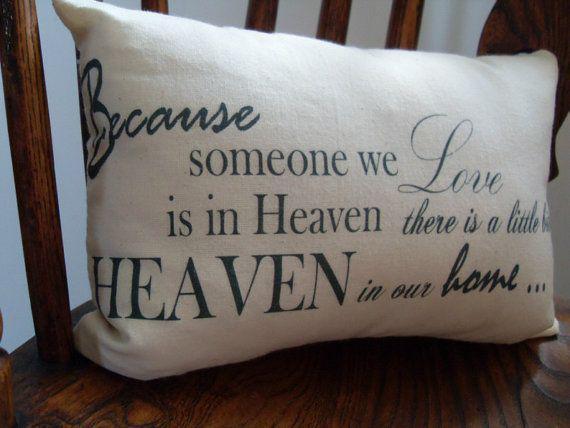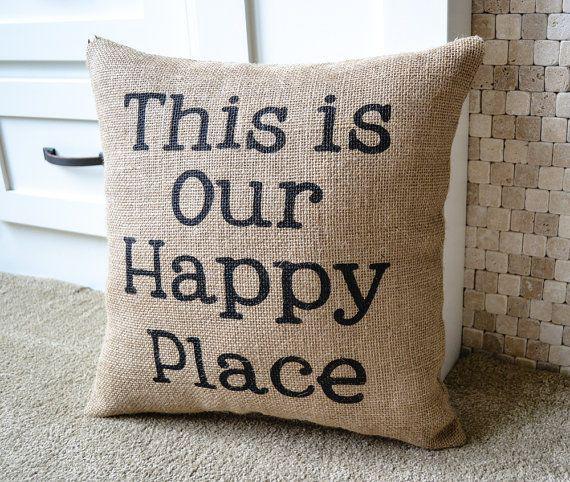The first image is the image on the left, the second image is the image on the right. Evaluate the accuracy of this statement regarding the images: "Two pillows with writing on them.". Is it true? Answer yes or no. Yes. The first image is the image on the left, the second image is the image on the right. Evaluate the accuracy of this statement regarding the images: "There is at least one throw blanket under at least one pillow.". Is it true? Answer yes or no. No. 